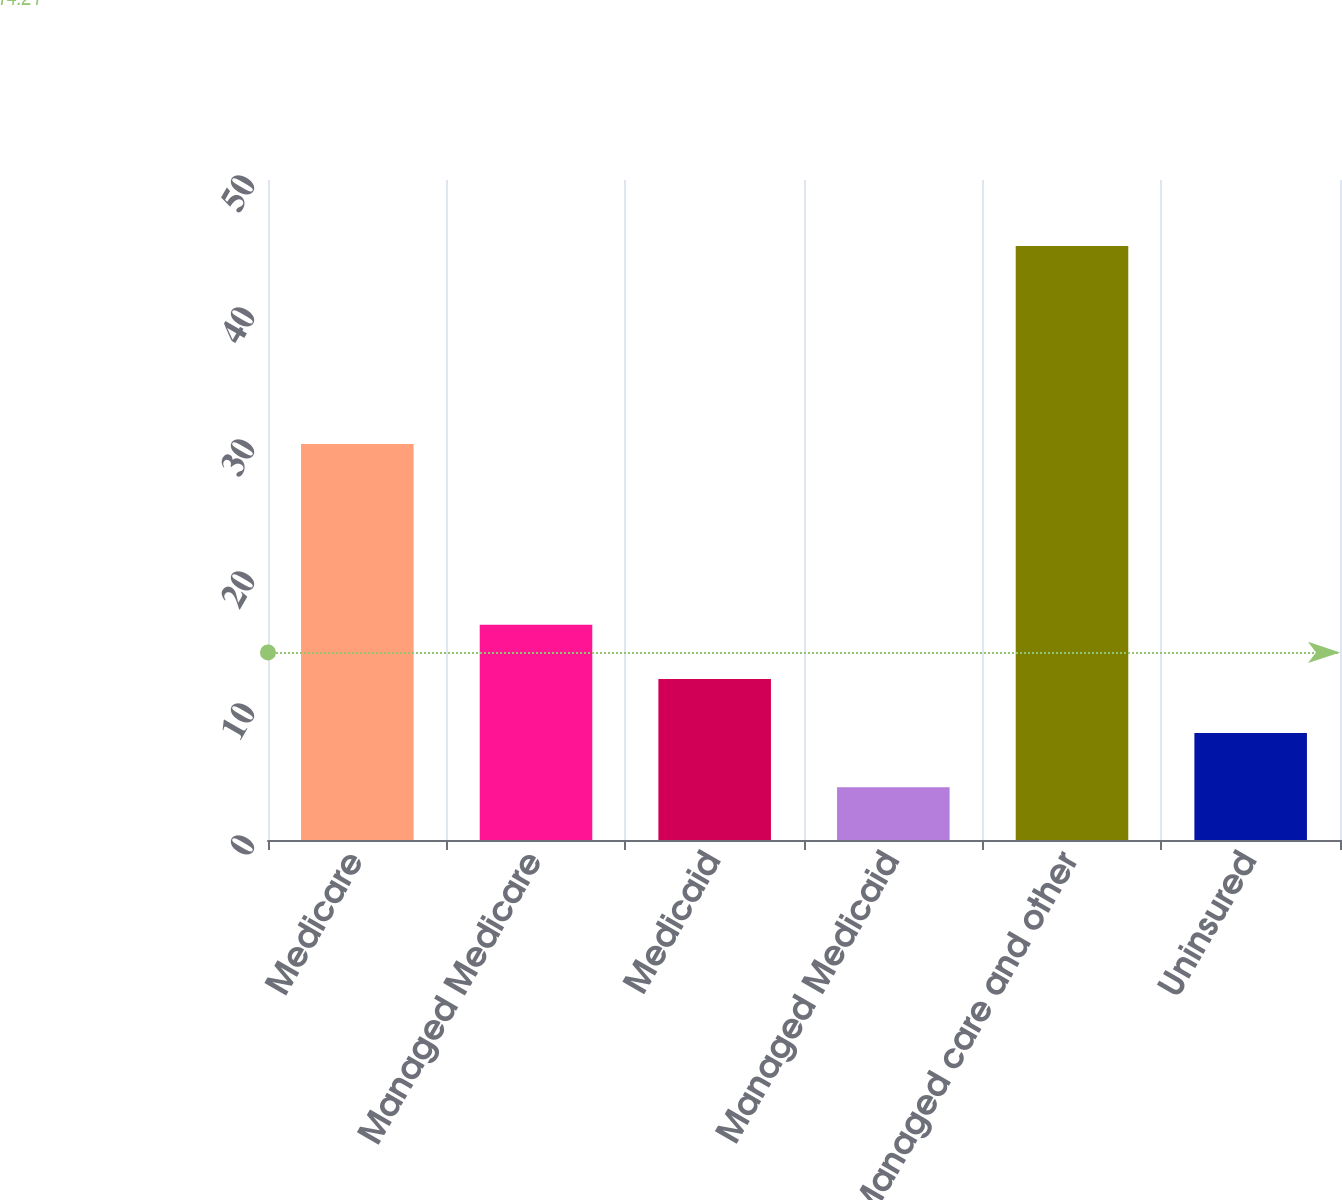Convert chart to OTSL. <chart><loc_0><loc_0><loc_500><loc_500><bar_chart><fcel>Medicare<fcel>Managed Medicare<fcel>Medicaid<fcel>Managed Medicaid<fcel>Managed care and other<fcel>Uninsured<nl><fcel>30<fcel>16.3<fcel>12.2<fcel>4<fcel>45<fcel>8.1<nl></chart> 